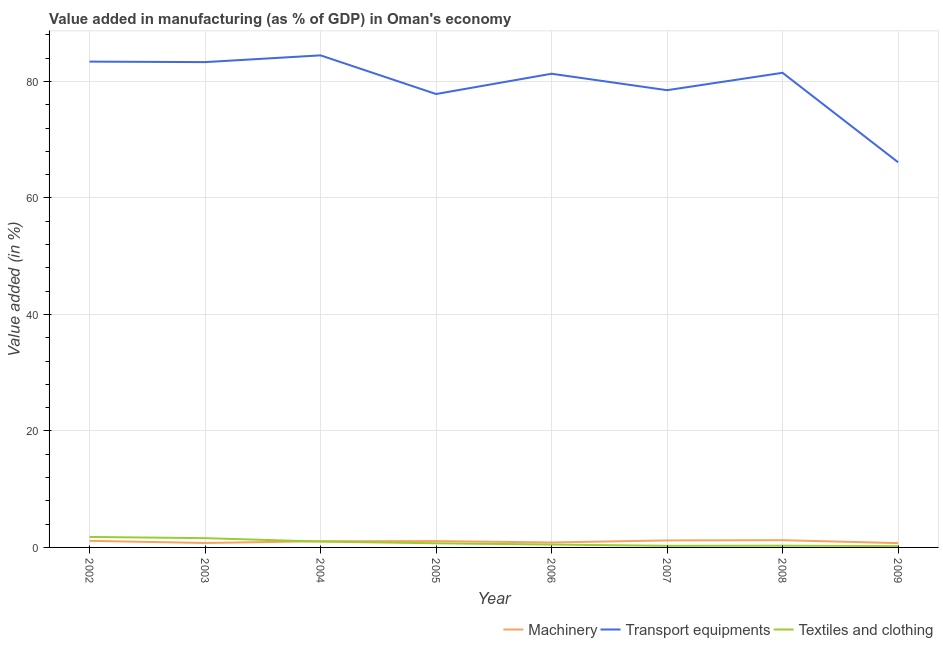How many different coloured lines are there?
Ensure brevity in your answer.  3. Does the line corresponding to value added in manufacturing machinery intersect with the line corresponding to value added in manufacturing textile and clothing?
Ensure brevity in your answer.  Yes. Is the number of lines equal to the number of legend labels?
Provide a short and direct response. Yes. What is the value added in manufacturing textile and clothing in 2006?
Your answer should be compact. 0.5. Across all years, what is the maximum value added in manufacturing machinery?
Provide a short and direct response. 1.25. Across all years, what is the minimum value added in manufacturing transport equipments?
Keep it short and to the point. 66.13. In which year was the value added in manufacturing machinery maximum?
Offer a terse response. 2008. What is the total value added in manufacturing machinery in the graph?
Keep it short and to the point. 8.09. What is the difference between the value added in manufacturing machinery in 2003 and that in 2008?
Ensure brevity in your answer.  -0.48. What is the difference between the value added in manufacturing textile and clothing in 2004 and the value added in manufacturing transport equipments in 2005?
Your response must be concise. -76.84. What is the average value added in manufacturing textile and clothing per year?
Your response must be concise. 0.8. In the year 2006, what is the difference between the value added in manufacturing machinery and value added in manufacturing transport equipments?
Keep it short and to the point. -80.48. In how many years, is the value added in manufacturing machinery greater than 72 %?
Ensure brevity in your answer.  0. What is the ratio of the value added in manufacturing textile and clothing in 2007 to that in 2008?
Make the answer very short. 0.93. Is the difference between the value added in manufacturing machinery in 2005 and 2009 greater than the difference between the value added in manufacturing textile and clothing in 2005 and 2009?
Give a very brief answer. No. What is the difference between the highest and the second highest value added in manufacturing machinery?
Your answer should be very brief. 0.04. What is the difference between the highest and the lowest value added in manufacturing textile and clothing?
Provide a short and direct response. 1.57. Does the value added in manufacturing machinery monotonically increase over the years?
Provide a succinct answer. No. Is the value added in manufacturing transport equipments strictly greater than the value added in manufacturing machinery over the years?
Your response must be concise. Yes. How many years are there in the graph?
Your answer should be compact. 8. Are the values on the major ticks of Y-axis written in scientific E-notation?
Offer a very short reply. No. Does the graph contain grids?
Ensure brevity in your answer.  Yes. How many legend labels are there?
Provide a short and direct response. 3. How are the legend labels stacked?
Offer a very short reply. Horizontal. What is the title of the graph?
Offer a very short reply. Value added in manufacturing (as % of GDP) in Oman's economy. What is the label or title of the Y-axis?
Provide a short and direct response. Value added (in %). What is the Value added (in %) in Machinery in 2002?
Provide a succinct answer. 1.13. What is the Value added (in %) in Transport equipments in 2002?
Provide a short and direct response. 83.41. What is the Value added (in %) in Textiles and clothing in 2002?
Provide a succinct answer. 1.8. What is the Value added (in %) in Machinery in 2003?
Keep it short and to the point. 0.76. What is the Value added (in %) of Transport equipments in 2003?
Your answer should be very brief. 83.33. What is the Value added (in %) in Textiles and clothing in 2003?
Your answer should be compact. 1.59. What is the Value added (in %) of Machinery in 2004?
Provide a short and direct response. 1.07. What is the Value added (in %) of Transport equipments in 2004?
Provide a short and direct response. 84.49. What is the Value added (in %) in Textiles and clothing in 2004?
Give a very brief answer. 1. What is the Value added (in %) in Machinery in 2005?
Your response must be concise. 1.09. What is the Value added (in %) in Transport equipments in 2005?
Ensure brevity in your answer.  77.85. What is the Value added (in %) of Textiles and clothing in 2005?
Provide a succinct answer. 0.71. What is the Value added (in %) of Machinery in 2006?
Give a very brief answer. 0.85. What is the Value added (in %) of Transport equipments in 2006?
Offer a very short reply. 81.33. What is the Value added (in %) of Textiles and clothing in 2006?
Make the answer very short. 0.5. What is the Value added (in %) in Machinery in 2007?
Offer a very short reply. 1.2. What is the Value added (in %) in Transport equipments in 2007?
Provide a short and direct response. 78.51. What is the Value added (in %) in Textiles and clothing in 2007?
Ensure brevity in your answer.  0.27. What is the Value added (in %) of Machinery in 2008?
Offer a terse response. 1.25. What is the Value added (in %) in Transport equipments in 2008?
Give a very brief answer. 81.49. What is the Value added (in %) in Textiles and clothing in 2008?
Provide a short and direct response. 0.29. What is the Value added (in %) in Machinery in 2009?
Your answer should be very brief. 0.74. What is the Value added (in %) in Transport equipments in 2009?
Your response must be concise. 66.13. What is the Value added (in %) in Textiles and clothing in 2009?
Your answer should be very brief. 0.23. Across all years, what is the maximum Value added (in %) of Machinery?
Provide a succinct answer. 1.25. Across all years, what is the maximum Value added (in %) in Transport equipments?
Offer a terse response. 84.49. Across all years, what is the maximum Value added (in %) of Textiles and clothing?
Give a very brief answer. 1.8. Across all years, what is the minimum Value added (in %) of Machinery?
Your response must be concise. 0.74. Across all years, what is the minimum Value added (in %) of Transport equipments?
Ensure brevity in your answer.  66.13. Across all years, what is the minimum Value added (in %) in Textiles and clothing?
Provide a succinct answer. 0.23. What is the total Value added (in %) in Machinery in the graph?
Provide a succinct answer. 8.09. What is the total Value added (in %) in Transport equipments in the graph?
Offer a terse response. 636.54. What is the total Value added (in %) in Textiles and clothing in the graph?
Ensure brevity in your answer.  6.39. What is the difference between the Value added (in %) in Machinery in 2002 and that in 2003?
Your answer should be very brief. 0.37. What is the difference between the Value added (in %) of Transport equipments in 2002 and that in 2003?
Keep it short and to the point. 0.09. What is the difference between the Value added (in %) in Textiles and clothing in 2002 and that in 2003?
Ensure brevity in your answer.  0.21. What is the difference between the Value added (in %) in Machinery in 2002 and that in 2004?
Your answer should be very brief. 0.07. What is the difference between the Value added (in %) of Transport equipments in 2002 and that in 2004?
Make the answer very short. -1.07. What is the difference between the Value added (in %) of Textiles and clothing in 2002 and that in 2004?
Make the answer very short. 0.8. What is the difference between the Value added (in %) of Machinery in 2002 and that in 2005?
Offer a terse response. 0.04. What is the difference between the Value added (in %) of Transport equipments in 2002 and that in 2005?
Offer a very short reply. 5.57. What is the difference between the Value added (in %) of Textiles and clothing in 2002 and that in 2005?
Ensure brevity in your answer.  1.09. What is the difference between the Value added (in %) in Machinery in 2002 and that in 2006?
Keep it short and to the point. 0.28. What is the difference between the Value added (in %) of Transport equipments in 2002 and that in 2006?
Ensure brevity in your answer.  2.08. What is the difference between the Value added (in %) of Textiles and clothing in 2002 and that in 2006?
Offer a terse response. 1.3. What is the difference between the Value added (in %) in Machinery in 2002 and that in 2007?
Keep it short and to the point. -0.07. What is the difference between the Value added (in %) of Transport equipments in 2002 and that in 2007?
Offer a terse response. 4.91. What is the difference between the Value added (in %) in Textiles and clothing in 2002 and that in 2007?
Your response must be concise. 1.53. What is the difference between the Value added (in %) in Machinery in 2002 and that in 2008?
Make the answer very short. -0.11. What is the difference between the Value added (in %) of Transport equipments in 2002 and that in 2008?
Ensure brevity in your answer.  1.92. What is the difference between the Value added (in %) of Textiles and clothing in 2002 and that in 2008?
Make the answer very short. 1.51. What is the difference between the Value added (in %) in Machinery in 2002 and that in 2009?
Offer a very short reply. 0.4. What is the difference between the Value added (in %) in Transport equipments in 2002 and that in 2009?
Provide a succinct answer. 17.28. What is the difference between the Value added (in %) in Textiles and clothing in 2002 and that in 2009?
Your response must be concise. 1.57. What is the difference between the Value added (in %) of Machinery in 2003 and that in 2004?
Your response must be concise. -0.3. What is the difference between the Value added (in %) of Transport equipments in 2003 and that in 2004?
Give a very brief answer. -1.16. What is the difference between the Value added (in %) in Textiles and clothing in 2003 and that in 2004?
Give a very brief answer. 0.59. What is the difference between the Value added (in %) of Machinery in 2003 and that in 2005?
Your answer should be compact. -0.33. What is the difference between the Value added (in %) of Transport equipments in 2003 and that in 2005?
Offer a very short reply. 5.48. What is the difference between the Value added (in %) in Textiles and clothing in 2003 and that in 2005?
Provide a succinct answer. 0.88. What is the difference between the Value added (in %) of Machinery in 2003 and that in 2006?
Offer a terse response. -0.09. What is the difference between the Value added (in %) in Transport equipments in 2003 and that in 2006?
Give a very brief answer. 2. What is the difference between the Value added (in %) of Textiles and clothing in 2003 and that in 2006?
Your answer should be compact. 1.09. What is the difference between the Value added (in %) of Machinery in 2003 and that in 2007?
Offer a very short reply. -0.44. What is the difference between the Value added (in %) in Transport equipments in 2003 and that in 2007?
Your answer should be very brief. 4.82. What is the difference between the Value added (in %) in Textiles and clothing in 2003 and that in 2007?
Give a very brief answer. 1.32. What is the difference between the Value added (in %) in Machinery in 2003 and that in 2008?
Your answer should be compact. -0.48. What is the difference between the Value added (in %) in Transport equipments in 2003 and that in 2008?
Offer a terse response. 1.84. What is the difference between the Value added (in %) in Textiles and clothing in 2003 and that in 2008?
Keep it short and to the point. 1.3. What is the difference between the Value added (in %) in Machinery in 2003 and that in 2009?
Offer a very short reply. 0.02. What is the difference between the Value added (in %) in Transport equipments in 2003 and that in 2009?
Provide a succinct answer. 17.19. What is the difference between the Value added (in %) of Textiles and clothing in 2003 and that in 2009?
Make the answer very short. 1.37. What is the difference between the Value added (in %) in Machinery in 2004 and that in 2005?
Provide a succinct answer. -0.03. What is the difference between the Value added (in %) of Transport equipments in 2004 and that in 2005?
Offer a terse response. 6.64. What is the difference between the Value added (in %) of Textiles and clothing in 2004 and that in 2005?
Provide a short and direct response. 0.29. What is the difference between the Value added (in %) in Machinery in 2004 and that in 2006?
Ensure brevity in your answer.  0.21. What is the difference between the Value added (in %) in Transport equipments in 2004 and that in 2006?
Your answer should be compact. 3.15. What is the difference between the Value added (in %) of Textiles and clothing in 2004 and that in 2006?
Provide a short and direct response. 0.51. What is the difference between the Value added (in %) in Machinery in 2004 and that in 2007?
Your answer should be very brief. -0.14. What is the difference between the Value added (in %) of Transport equipments in 2004 and that in 2007?
Give a very brief answer. 5.98. What is the difference between the Value added (in %) in Textiles and clothing in 2004 and that in 2007?
Make the answer very short. 0.73. What is the difference between the Value added (in %) of Machinery in 2004 and that in 2008?
Your answer should be compact. -0.18. What is the difference between the Value added (in %) of Transport equipments in 2004 and that in 2008?
Your answer should be very brief. 2.99. What is the difference between the Value added (in %) of Textiles and clothing in 2004 and that in 2008?
Make the answer very short. 0.71. What is the difference between the Value added (in %) of Machinery in 2004 and that in 2009?
Your response must be concise. 0.33. What is the difference between the Value added (in %) of Transport equipments in 2004 and that in 2009?
Provide a succinct answer. 18.35. What is the difference between the Value added (in %) of Textiles and clothing in 2004 and that in 2009?
Keep it short and to the point. 0.78. What is the difference between the Value added (in %) of Machinery in 2005 and that in 2006?
Ensure brevity in your answer.  0.24. What is the difference between the Value added (in %) of Transport equipments in 2005 and that in 2006?
Offer a terse response. -3.48. What is the difference between the Value added (in %) in Textiles and clothing in 2005 and that in 2006?
Provide a succinct answer. 0.22. What is the difference between the Value added (in %) in Machinery in 2005 and that in 2007?
Keep it short and to the point. -0.11. What is the difference between the Value added (in %) in Transport equipments in 2005 and that in 2007?
Keep it short and to the point. -0.66. What is the difference between the Value added (in %) in Textiles and clothing in 2005 and that in 2007?
Your response must be concise. 0.44. What is the difference between the Value added (in %) in Machinery in 2005 and that in 2008?
Ensure brevity in your answer.  -0.15. What is the difference between the Value added (in %) in Transport equipments in 2005 and that in 2008?
Your answer should be very brief. -3.64. What is the difference between the Value added (in %) in Textiles and clothing in 2005 and that in 2008?
Provide a short and direct response. 0.42. What is the difference between the Value added (in %) of Machinery in 2005 and that in 2009?
Your answer should be compact. 0.35. What is the difference between the Value added (in %) of Transport equipments in 2005 and that in 2009?
Keep it short and to the point. 11.71. What is the difference between the Value added (in %) of Textiles and clothing in 2005 and that in 2009?
Make the answer very short. 0.49. What is the difference between the Value added (in %) of Machinery in 2006 and that in 2007?
Offer a terse response. -0.35. What is the difference between the Value added (in %) of Transport equipments in 2006 and that in 2007?
Your answer should be compact. 2.82. What is the difference between the Value added (in %) of Textiles and clothing in 2006 and that in 2007?
Your answer should be very brief. 0.22. What is the difference between the Value added (in %) of Machinery in 2006 and that in 2008?
Provide a succinct answer. -0.39. What is the difference between the Value added (in %) in Transport equipments in 2006 and that in 2008?
Provide a succinct answer. -0.16. What is the difference between the Value added (in %) of Textiles and clothing in 2006 and that in 2008?
Your answer should be compact. 0.2. What is the difference between the Value added (in %) of Machinery in 2006 and that in 2009?
Give a very brief answer. 0.11. What is the difference between the Value added (in %) of Transport equipments in 2006 and that in 2009?
Make the answer very short. 15.2. What is the difference between the Value added (in %) in Textiles and clothing in 2006 and that in 2009?
Provide a short and direct response. 0.27. What is the difference between the Value added (in %) in Machinery in 2007 and that in 2008?
Offer a terse response. -0.04. What is the difference between the Value added (in %) in Transport equipments in 2007 and that in 2008?
Your answer should be very brief. -2.98. What is the difference between the Value added (in %) in Textiles and clothing in 2007 and that in 2008?
Your answer should be very brief. -0.02. What is the difference between the Value added (in %) of Machinery in 2007 and that in 2009?
Offer a terse response. 0.46. What is the difference between the Value added (in %) in Transport equipments in 2007 and that in 2009?
Give a very brief answer. 12.37. What is the difference between the Value added (in %) of Textiles and clothing in 2007 and that in 2009?
Provide a succinct answer. 0.05. What is the difference between the Value added (in %) in Machinery in 2008 and that in 2009?
Provide a short and direct response. 0.51. What is the difference between the Value added (in %) in Transport equipments in 2008 and that in 2009?
Keep it short and to the point. 15.36. What is the difference between the Value added (in %) in Textiles and clothing in 2008 and that in 2009?
Keep it short and to the point. 0.07. What is the difference between the Value added (in %) in Machinery in 2002 and the Value added (in %) in Transport equipments in 2003?
Give a very brief answer. -82.19. What is the difference between the Value added (in %) in Machinery in 2002 and the Value added (in %) in Textiles and clothing in 2003?
Provide a succinct answer. -0.46. What is the difference between the Value added (in %) in Transport equipments in 2002 and the Value added (in %) in Textiles and clothing in 2003?
Offer a very short reply. 81.82. What is the difference between the Value added (in %) in Machinery in 2002 and the Value added (in %) in Transport equipments in 2004?
Give a very brief answer. -83.35. What is the difference between the Value added (in %) in Machinery in 2002 and the Value added (in %) in Textiles and clothing in 2004?
Your answer should be very brief. 0.13. What is the difference between the Value added (in %) of Transport equipments in 2002 and the Value added (in %) of Textiles and clothing in 2004?
Your answer should be very brief. 82.41. What is the difference between the Value added (in %) in Machinery in 2002 and the Value added (in %) in Transport equipments in 2005?
Provide a short and direct response. -76.71. What is the difference between the Value added (in %) in Machinery in 2002 and the Value added (in %) in Textiles and clothing in 2005?
Offer a very short reply. 0.42. What is the difference between the Value added (in %) in Transport equipments in 2002 and the Value added (in %) in Textiles and clothing in 2005?
Provide a succinct answer. 82.7. What is the difference between the Value added (in %) in Machinery in 2002 and the Value added (in %) in Transport equipments in 2006?
Make the answer very short. -80.2. What is the difference between the Value added (in %) of Machinery in 2002 and the Value added (in %) of Textiles and clothing in 2006?
Your response must be concise. 0.64. What is the difference between the Value added (in %) in Transport equipments in 2002 and the Value added (in %) in Textiles and clothing in 2006?
Provide a short and direct response. 82.92. What is the difference between the Value added (in %) in Machinery in 2002 and the Value added (in %) in Transport equipments in 2007?
Your answer should be compact. -77.37. What is the difference between the Value added (in %) in Machinery in 2002 and the Value added (in %) in Textiles and clothing in 2007?
Give a very brief answer. 0.86. What is the difference between the Value added (in %) of Transport equipments in 2002 and the Value added (in %) of Textiles and clothing in 2007?
Keep it short and to the point. 83.14. What is the difference between the Value added (in %) in Machinery in 2002 and the Value added (in %) in Transport equipments in 2008?
Ensure brevity in your answer.  -80.36. What is the difference between the Value added (in %) in Machinery in 2002 and the Value added (in %) in Textiles and clothing in 2008?
Provide a short and direct response. 0.84. What is the difference between the Value added (in %) in Transport equipments in 2002 and the Value added (in %) in Textiles and clothing in 2008?
Make the answer very short. 83.12. What is the difference between the Value added (in %) of Machinery in 2002 and the Value added (in %) of Transport equipments in 2009?
Offer a terse response. -65. What is the difference between the Value added (in %) in Machinery in 2002 and the Value added (in %) in Textiles and clothing in 2009?
Keep it short and to the point. 0.91. What is the difference between the Value added (in %) of Transport equipments in 2002 and the Value added (in %) of Textiles and clothing in 2009?
Offer a terse response. 83.19. What is the difference between the Value added (in %) in Machinery in 2003 and the Value added (in %) in Transport equipments in 2004?
Your answer should be very brief. -83.72. What is the difference between the Value added (in %) of Machinery in 2003 and the Value added (in %) of Textiles and clothing in 2004?
Your answer should be compact. -0.24. What is the difference between the Value added (in %) in Transport equipments in 2003 and the Value added (in %) in Textiles and clothing in 2004?
Give a very brief answer. 82.32. What is the difference between the Value added (in %) in Machinery in 2003 and the Value added (in %) in Transport equipments in 2005?
Keep it short and to the point. -77.08. What is the difference between the Value added (in %) of Machinery in 2003 and the Value added (in %) of Textiles and clothing in 2005?
Give a very brief answer. 0.05. What is the difference between the Value added (in %) of Transport equipments in 2003 and the Value added (in %) of Textiles and clothing in 2005?
Make the answer very short. 82.61. What is the difference between the Value added (in %) in Machinery in 2003 and the Value added (in %) in Transport equipments in 2006?
Make the answer very short. -80.57. What is the difference between the Value added (in %) of Machinery in 2003 and the Value added (in %) of Textiles and clothing in 2006?
Keep it short and to the point. 0.27. What is the difference between the Value added (in %) of Transport equipments in 2003 and the Value added (in %) of Textiles and clothing in 2006?
Your answer should be very brief. 82.83. What is the difference between the Value added (in %) of Machinery in 2003 and the Value added (in %) of Transport equipments in 2007?
Provide a short and direct response. -77.74. What is the difference between the Value added (in %) in Machinery in 2003 and the Value added (in %) in Textiles and clothing in 2007?
Your response must be concise. 0.49. What is the difference between the Value added (in %) in Transport equipments in 2003 and the Value added (in %) in Textiles and clothing in 2007?
Offer a terse response. 83.05. What is the difference between the Value added (in %) in Machinery in 2003 and the Value added (in %) in Transport equipments in 2008?
Provide a succinct answer. -80.73. What is the difference between the Value added (in %) of Machinery in 2003 and the Value added (in %) of Textiles and clothing in 2008?
Your response must be concise. 0.47. What is the difference between the Value added (in %) in Transport equipments in 2003 and the Value added (in %) in Textiles and clothing in 2008?
Ensure brevity in your answer.  83.03. What is the difference between the Value added (in %) in Machinery in 2003 and the Value added (in %) in Transport equipments in 2009?
Your answer should be compact. -65.37. What is the difference between the Value added (in %) of Machinery in 2003 and the Value added (in %) of Textiles and clothing in 2009?
Make the answer very short. 0.54. What is the difference between the Value added (in %) in Transport equipments in 2003 and the Value added (in %) in Textiles and clothing in 2009?
Your answer should be compact. 83.1. What is the difference between the Value added (in %) of Machinery in 2004 and the Value added (in %) of Transport equipments in 2005?
Your response must be concise. -76.78. What is the difference between the Value added (in %) of Machinery in 2004 and the Value added (in %) of Textiles and clothing in 2005?
Give a very brief answer. 0.35. What is the difference between the Value added (in %) in Transport equipments in 2004 and the Value added (in %) in Textiles and clothing in 2005?
Keep it short and to the point. 83.77. What is the difference between the Value added (in %) in Machinery in 2004 and the Value added (in %) in Transport equipments in 2006?
Provide a short and direct response. -80.27. What is the difference between the Value added (in %) in Machinery in 2004 and the Value added (in %) in Textiles and clothing in 2006?
Your answer should be compact. 0.57. What is the difference between the Value added (in %) in Transport equipments in 2004 and the Value added (in %) in Textiles and clothing in 2006?
Your response must be concise. 83.99. What is the difference between the Value added (in %) of Machinery in 2004 and the Value added (in %) of Transport equipments in 2007?
Offer a very short reply. -77.44. What is the difference between the Value added (in %) of Machinery in 2004 and the Value added (in %) of Textiles and clothing in 2007?
Offer a very short reply. 0.79. What is the difference between the Value added (in %) of Transport equipments in 2004 and the Value added (in %) of Textiles and clothing in 2007?
Your answer should be compact. 84.21. What is the difference between the Value added (in %) in Machinery in 2004 and the Value added (in %) in Transport equipments in 2008?
Your response must be concise. -80.43. What is the difference between the Value added (in %) in Machinery in 2004 and the Value added (in %) in Textiles and clothing in 2008?
Keep it short and to the point. 0.77. What is the difference between the Value added (in %) of Transport equipments in 2004 and the Value added (in %) of Textiles and clothing in 2008?
Offer a terse response. 84.19. What is the difference between the Value added (in %) of Machinery in 2004 and the Value added (in %) of Transport equipments in 2009?
Your answer should be very brief. -65.07. What is the difference between the Value added (in %) of Machinery in 2004 and the Value added (in %) of Textiles and clothing in 2009?
Provide a succinct answer. 0.84. What is the difference between the Value added (in %) of Transport equipments in 2004 and the Value added (in %) of Textiles and clothing in 2009?
Your response must be concise. 84.26. What is the difference between the Value added (in %) of Machinery in 2005 and the Value added (in %) of Transport equipments in 2006?
Provide a short and direct response. -80.24. What is the difference between the Value added (in %) of Machinery in 2005 and the Value added (in %) of Textiles and clothing in 2006?
Give a very brief answer. 0.6. What is the difference between the Value added (in %) of Transport equipments in 2005 and the Value added (in %) of Textiles and clothing in 2006?
Your answer should be very brief. 77.35. What is the difference between the Value added (in %) of Machinery in 2005 and the Value added (in %) of Transport equipments in 2007?
Offer a terse response. -77.42. What is the difference between the Value added (in %) in Machinery in 2005 and the Value added (in %) in Textiles and clothing in 2007?
Ensure brevity in your answer.  0.82. What is the difference between the Value added (in %) in Transport equipments in 2005 and the Value added (in %) in Textiles and clothing in 2007?
Offer a terse response. 77.57. What is the difference between the Value added (in %) in Machinery in 2005 and the Value added (in %) in Transport equipments in 2008?
Offer a very short reply. -80.4. What is the difference between the Value added (in %) in Machinery in 2005 and the Value added (in %) in Textiles and clothing in 2008?
Make the answer very short. 0.8. What is the difference between the Value added (in %) of Transport equipments in 2005 and the Value added (in %) of Textiles and clothing in 2008?
Provide a short and direct response. 77.55. What is the difference between the Value added (in %) in Machinery in 2005 and the Value added (in %) in Transport equipments in 2009?
Your answer should be very brief. -65.04. What is the difference between the Value added (in %) in Machinery in 2005 and the Value added (in %) in Textiles and clothing in 2009?
Provide a short and direct response. 0.87. What is the difference between the Value added (in %) in Transport equipments in 2005 and the Value added (in %) in Textiles and clothing in 2009?
Provide a succinct answer. 77.62. What is the difference between the Value added (in %) of Machinery in 2006 and the Value added (in %) of Transport equipments in 2007?
Make the answer very short. -77.65. What is the difference between the Value added (in %) in Machinery in 2006 and the Value added (in %) in Textiles and clothing in 2007?
Give a very brief answer. 0.58. What is the difference between the Value added (in %) of Transport equipments in 2006 and the Value added (in %) of Textiles and clothing in 2007?
Provide a succinct answer. 81.06. What is the difference between the Value added (in %) in Machinery in 2006 and the Value added (in %) in Transport equipments in 2008?
Offer a very short reply. -80.64. What is the difference between the Value added (in %) in Machinery in 2006 and the Value added (in %) in Textiles and clothing in 2008?
Provide a short and direct response. 0.56. What is the difference between the Value added (in %) of Transport equipments in 2006 and the Value added (in %) of Textiles and clothing in 2008?
Provide a succinct answer. 81.04. What is the difference between the Value added (in %) of Machinery in 2006 and the Value added (in %) of Transport equipments in 2009?
Make the answer very short. -65.28. What is the difference between the Value added (in %) in Machinery in 2006 and the Value added (in %) in Textiles and clothing in 2009?
Offer a terse response. 0.63. What is the difference between the Value added (in %) of Transport equipments in 2006 and the Value added (in %) of Textiles and clothing in 2009?
Offer a terse response. 81.11. What is the difference between the Value added (in %) of Machinery in 2007 and the Value added (in %) of Transport equipments in 2008?
Offer a very short reply. -80.29. What is the difference between the Value added (in %) of Machinery in 2007 and the Value added (in %) of Textiles and clothing in 2008?
Provide a succinct answer. 0.91. What is the difference between the Value added (in %) of Transport equipments in 2007 and the Value added (in %) of Textiles and clothing in 2008?
Your response must be concise. 78.21. What is the difference between the Value added (in %) in Machinery in 2007 and the Value added (in %) in Transport equipments in 2009?
Make the answer very short. -64.93. What is the difference between the Value added (in %) of Machinery in 2007 and the Value added (in %) of Textiles and clothing in 2009?
Offer a very short reply. 0.98. What is the difference between the Value added (in %) of Transport equipments in 2007 and the Value added (in %) of Textiles and clothing in 2009?
Provide a short and direct response. 78.28. What is the difference between the Value added (in %) of Machinery in 2008 and the Value added (in %) of Transport equipments in 2009?
Your answer should be very brief. -64.89. What is the difference between the Value added (in %) in Machinery in 2008 and the Value added (in %) in Textiles and clothing in 2009?
Provide a succinct answer. 1.02. What is the difference between the Value added (in %) in Transport equipments in 2008 and the Value added (in %) in Textiles and clothing in 2009?
Offer a very short reply. 81.27. What is the average Value added (in %) in Machinery per year?
Offer a terse response. 1.01. What is the average Value added (in %) in Transport equipments per year?
Keep it short and to the point. 79.57. What is the average Value added (in %) in Textiles and clothing per year?
Make the answer very short. 0.8. In the year 2002, what is the difference between the Value added (in %) of Machinery and Value added (in %) of Transport equipments?
Your answer should be compact. -82.28. In the year 2002, what is the difference between the Value added (in %) in Machinery and Value added (in %) in Textiles and clothing?
Offer a terse response. -0.67. In the year 2002, what is the difference between the Value added (in %) in Transport equipments and Value added (in %) in Textiles and clothing?
Make the answer very short. 81.61. In the year 2003, what is the difference between the Value added (in %) in Machinery and Value added (in %) in Transport equipments?
Offer a terse response. -82.57. In the year 2003, what is the difference between the Value added (in %) in Machinery and Value added (in %) in Textiles and clothing?
Your answer should be very brief. -0.83. In the year 2003, what is the difference between the Value added (in %) in Transport equipments and Value added (in %) in Textiles and clothing?
Offer a very short reply. 81.74. In the year 2004, what is the difference between the Value added (in %) in Machinery and Value added (in %) in Transport equipments?
Give a very brief answer. -83.42. In the year 2004, what is the difference between the Value added (in %) in Machinery and Value added (in %) in Textiles and clothing?
Provide a succinct answer. 0.06. In the year 2004, what is the difference between the Value added (in %) in Transport equipments and Value added (in %) in Textiles and clothing?
Ensure brevity in your answer.  83.48. In the year 2005, what is the difference between the Value added (in %) of Machinery and Value added (in %) of Transport equipments?
Give a very brief answer. -76.76. In the year 2005, what is the difference between the Value added (in %) in Machinery and Value added (in %) in Textiles and clothing?
Provide a succinct answer. 0.38. In the year 2005, what is the difference between the Value added (in %) of Transport equipments and Value added (in %) of Textiles and clothing?
Provide a short and direct response. 77.13. In the year 2006, what is the difference between the Value added (in %) in Machinery and Value added (in %) in Transport equipments?
Give a very brief answer. -80.48. In the year 2006, what is the difference between the Value added (in %) of Machinery and Value added (in %) of Textiles and clothing?
Offer a terse response. 0.36. In the year 2006, what is the difference between the Value added (in %) of Transport equipments and Value added (in %) of Textiles and clothing?
Provide a short and direct response. 80.84. In the year 2007, what is the difference between the Value added (in %) in Machinery and Value added (in %) in Transport equipments?
Your answer should be compact. -77.3. In the year 2007, what is the difference between the Value added (in %) of Machinery and Value added (in %) of Textiles and clothing?
Offer a terse response. 0.93. In the year 2007, what is the difference between the Value added (in %) of Transport equipments and Value added (in %) of Textiles and clothing?
Your answer should be very brief. 78.23. In the year 2008, what is the difference between the Value added (in %) in Machinery and Value added (in %) in Transport equipments?
Provide a succinct answer. -80.25. In the year 2008, what is the difference between the Value added (in %) in Machinery and Value added (in %) in Textiles and clothing?
Give a very brief answer. 0.95. In the year 2008, what is the difference between the Value added (in %) in Transport equipments and Value added (in %) in Textiles and clothing?
Offer a very short reply. 81.2. In the year 2009, what is the difference between the Value added (in %) of Machinery and Value added (in %) of Transport equipments?
Keep it short and to the point. -65.4. In the year 2009, what is the difference between the Value added (in %) of Machinery and Value added (in %) of Textiles and clothing?
Your answer should be very brief. 0.51. In the year 2009, what is the difference between the Value added (in %) in Transport equipments and Value added (in %) in Textiles and clothing?
Give a very brief answer. 65.91. What is the ratio of the Value added (in %) of Machinery in 2002 to that in 2003?
Provide a short and direct response. 1.49. What is the ratio of the Value added (in %) of Textiles and clothing in 2002 to that in 2003?
Your response must be concise. 1.13. What is the ratio of the Value added (in %) in Machinery in 2002 to that in 2004?
Make the answer very short. 1.06. What is the ratio of the Value added (in %) of Transport equipments in 2002 to that in 2004?
Provide a succinct answer. 0.99. What is the ratio of the Value added (in %) of Textiles and clothing in 2002 to that in 2004?
Ensure brevity in your answer.  1.79. What is the ratio of the Value added (in %) of Machinery in 2002 to that in 2005?
Offer a terse response. 1.04. What is the ratio of the Value added (in %) of Transport equipments in 2002 to that in 2005?
Your response must be concise. 1.07. What is the ratio of the Value added (in %) in Textiles and clothing in 2002 to that in 2005?
Your response must be concise. 2.52. What is the ratio of the Value added (in %) in Machinery in 2002 to that in 2006?
Your response must be concise. 1.33. What is the ratio of the Value added (in %) in Transport equipments in 2002 to that in 2006?
Offer a terse response. 1.03. What is the ratio of the Value added (in %) in Textiles and clothing in 2002 to that in 2006?
Offer a terse response. 3.63. What is the ratio of the Value added (in %) in Machinery in 2002 to that in 2007?
Offer a very short reply. 0.94. What is the ratio of the Value added (in %) of Textiles and clothing in 2002 to that in 2007?
Keep it short and to the point. 6.59. What is the ratio of the Value added (in %) in Machinery in 2002 to that in 2008?
Offer a very short reply. 0.91. What is the ratio of the Value added (in %) of Transport equipments in 2002 to that in 2008?
Offer a very short reply. 1.02. What is the ratio of the Value added (in %) in Textiles and clothing in 2002 to that in 2008?
Provide a succinct answer. 6.11. What is the ratio of the Value added (in %) in Machinery in 2002 to that in 2009?
Your answer should be compact. 1.54. What is the ratio of the Value added (in %) in Transport equipments in 2002 to that in 2009?
Offer a very short reply. 1.26. What is the ratio of the Value added (in %) of Textiles and clothing in 2002 to that in 2009?
Your answer should be compact. 8. What is the ratio of the Value added (in %) in Machinery in 2003 to that in 2004?
Your answer should be compact. 0.72. What is the ratio of the Value added (in %) in Transport equipments in 2003 to that in 2004?
Ensure brevity in your answer.  0.99. What is the ratio of the Value added (in %) in Textiles and clothing in 2003 to that in 2004?
Offer a very short reply. 1.59. What is the ratio of the Value added (in %) in Machinery in 2003 to that in 2005?
Give a very brief answer. 0.7. What is the ratio of the Value added (in %) in Transport equipments in 2003 to that in 2005?
Offer a very short reply. 1.07. What is the ratio of the Value added (in %) of Textiles and clothing in 2003 to that in 2005?
Make the answer very short. 2.23. What is the ratio of the Value added (in %) of Machinery in 2003 to that in 2006?
Make the answer very short. 0.89. What is the ratio of the Value added (in %) in Transport equipments in 2003 to that in 2006?
Your answer should be very brief. 1.02. What is the ratio of the Value added (in %) of Textiles and clothing in 2003 to that in 2006?
Your response must be concise. 3.21. What is the ratio of the Value added (in %) in Machinery in 2003 to that in 2007?
Ensure brevity in your answer.  0.63. What is the ratio of the Value added (in %) in Transport equipments in 2003 to that in 2007?
Provide a short and direct response. 1.06. What is the ratio of the Value added (in %) of Textiles and clothing in 2003 to that in 2007?
Your answer should be compact. 5.82. What is the ratio of the Value added (in %) of Machinery in 2003 to that in 2008?
Keep it short and to the point. 0.61. What is the ratio of the Value added (in %) in Transport equipments in 2003 to that in 2008?
Offer a very short reply. 1.02. What is the ratio of the Value added (in %) of Textiles and clothing in 2003 to that in 2008?
Your answer should be compact. 5.4. What is the ratio of the Value added (in %) of Machinery in 2003 to that in 2009?
Your answer should be very brief. 1.03. What is the ratio of the Value added (in %) of Transport equipments in 2003 to that in 2009?
Your response must be concise. 1.26. What is the ratio of the Value added (in %) in Textiles and clothing in 2003 to that in 2009?
Provide a succinct answer. 7.07. What is the ratio of the Value added (in %) of Machinery in 2004 to that in 2005?
Your answer should be compact. 0.98. What is the ratio of the Value added (in %) in Transport equipments in 2004 to that in 2005?
Keep it short and to the point. 1.09. What is the ratio of the Value added (in %) in Textiles and clothing in 2004 to that in 2005?
Provide a short and direct response. 1.41. What is the ratio of the Value added (in %) of Machinery in 2004 to that in 2006?
Provide a succinct answer. 1.25. What is the ratio of the Value added (in %) in Transport equipments in 2004 to that in 2006?
Your answer should be very brief. 1.04. What is the ratio of the Value added (in %) of Textiles and clothing in 2004 to that in 2006?
Keep it short and to the point. 2.02. What is the ratio of the Value added (in %) in Machinery in 2004 to that in 2007?
Your answer should be very brief. 0.89. What is the ratio of the Value added (in %) in Transport equipments in 2004 to that in 2007?
Your answer should be compact. 1.08. What is the ratio of the Value added (in %) in Textiles and clothing in 2004 to that in 2007?
Your response must be concise. 3.67. What is the ratio of the Value added (in %) of Machinery in 2004 to that in 2008?
Keep it short and to the point. 0.86. What is the ratio of the Value added (in %) of Transport equipments in 2004 to that in 2008?
Keep it short and to the point. 1.04. What is the ratio of the Value added (in %) in Textiles and clothing in 2004 to that in 2008?
Your response must be concise. 3.4. What is the ratio of the Value added (in %) in Machinery in 2004 to that in 2009?
Offer a very short reply. 1.44. What is the ratio of the Value added (in %) in Transport equipments in 2004 to that in 2009?
Provide a succinct answer. 1.28. What is the ratio of the Value added (in %) of Textiles and clothing in 2004 to that in 2009?
Offer a very short reply. 4.46. What is the ratio of the Value added (in %) of Machinery in 2005 to that in 2006?
Ensure brevity in your answer.  1.28. What is the ratio of the Value added (in %) of Transport equipments in 2005 to that in 2006?
Provide a succinct answer. 0.96. What is the ratio of the Value added (in %) of Textiles and clothing in 2005 to that in 2006?
Offer a terse response. 1.44. What is the ratio of the Value added (in %) of Machinery in 2005 to that in 2007?
Offer a terse response. 0.91. What is the ratio of the Value added (in %) in Transport equipments in 2005 to that in 2007?
Keep it short and to the point. 0.99. What is the ratio of the Value added (in %) in Textiles and clothing in 2005 to that in 2007?
Offer a very short reply. 2.61. What is the ratio of the Value added (in %) in Machinery in 2005 to that in 2008?
Offer a very short reply. 0.88. What is the ratio of the Value added (in %) of Transport equipments in 2005 to that in 2008?
Offer a terse response. 0.96. What is the ratio of the Value added (in %) in Textiles and clothing in 2005 to that in 2008?
Offer a very short reply. 2.42. What is the ratio of the Value added (in %) in Machinery in 2005 to that in 2009?
Ensure brevity in your answer.  1.48. What is the ratio of the Value added (in %) of Transport equipments in 2005 to that in 2009?
Offer a very short reply. 1.18. What is the ratio of the Value added (in %) of Textiles and clothing in 2005 to that in 2009?
Offer a terse response. 3.17. What is the ratio of the Value added (in %) of Machinery in 2006 to that in 2007?
Provide a short and direct response. 0.71. What is the ratio of the Value added (in %) of Transport equipments in 2006 to that in 2007?
Your response must be concise. 1.04. What is the ratio of the Value added (in %) of Textiles and clothing in 2006 to that in 2007?
Your answer should be compact. 1.81. What is the ratio of the Value added (in %) in Machinery in 2006 to that in 2008?
Your answer should be very brief. 0.68. What is the ratio of the Value added (in %) in Transport equipments in 2006 to that in 2008?
Keep it short and to the point. 1. What is the ratio of the Value added (in %) of Textiles and clothing in 2006 to that in 2008?
Offer a terse response. 1.68. What is the ratio of the Value added (in %) in Machinery in 2006 to that in 2009?
Provide a succinct answer. 1.16. What is the ratio of the Value added (in %) of Transport equipments in 2006 to that in 2009?
Ensure brevity in your answer.  1.23. What is the ratio of the Value added (in %) of Textiles and clothing in 2006 to that in 2009?
Your response must be concise. 2.2. What is the ratio of the Value added (in %) of Machinery in 2007 to that in 2008?
Your response must be concise. 0.96. What is the ratio of the Value added (in %) in Transport equipments in 2007 to that in 2008?
Make the answer very short. 0.96. What is the ratio of the Value added (in %) in Textiles and clothing in 2007 to that in 2008?
Provide a succinct answer. 0.93. What is the ratio of the Value added (in %) in Machinery in 2007 to that in 2009?
Keep it short and to the point. 1.63. What is the ratio of the Value added (in %) of Transport equipments in 2007 to that in 2009?
Provide a succinct answer. 1.19. What is the ratio of the Value added (in %) of Textiles and clothing in 2007 to that in 2009?
Give a very brief answer. 1.21. What is the ratio of the Value added (in %) in Machinery in 2008 to that in 2009?
Keep it short and to the point. 1.69. What is the ratio of the Value added (in %) in Transport equipments in 2008 to that in 2009?
Offer a terse response. 1.23. What is the ratio of the Value added (in %) in Textiles and clothing in 2008 to that in 2009?
Your answer should be compact. 1.31. What is the difference between the highest and the second highest Value added (in %) in Machinery?
Offer a very short reply. 0.04. What is the difference between the highest and the second highest Value added (in %) in Transport equipments?
Give a very brief answer. 1.07. What is the difference between the highest and the second highest Value added (in %) of Textiles and clothing?
Provide a succinct answer. 0.21. What is the difference between the highest and the lowest Value added (in %) of Machinery?
Ensure brevity in your answer.  0.51. What is the difference between the highest and the lowest Value added (in %) in Transport equipments?
Ensure brevity in your answer.  18.35. What is the difference between the highest and the lowest Value added (in %) in Textiles and clothing?
Give a very brief answer. 1.57. 